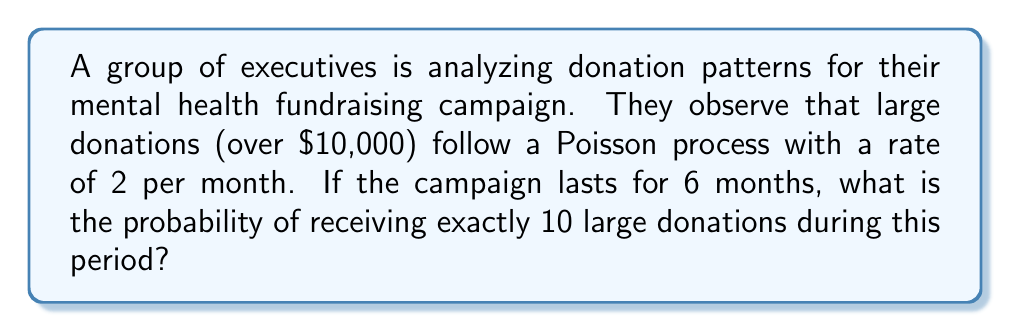Teach me how to tackle this problem. To solve this problem, we'll use the Poisson distribution formula:

$$P(X = k) = \frac{e^{-\lambda} \lambda^k}{k!}$$

Where:
- $\lambda$ is the average number of events in the given time period
- $k$ is the number of events we're interested in
- $e$ is Euler's number (approximately 2.71828)

Step 1: Calculate $\lambda$ for the entire 6-month period
$\lambda = 2 \text{ donations/month} \times 6 \text{ months} = 12 \text{ donations}$

Step 2: Apply the Poisson distribution formula with $k = 10$ and $\lambda = 12$

$$P(X = 10) = \frac{e^{-12} 12^{10}}{10!}$$

Step 3: Calculate the numerator and denominator separately

Numerator: $e^{-12} \times 12^{10} \approx 0.000006144 \times 61,917,364,224 \approx 380.4$

Denominator: $10! = 3,628,800$

Step 4: Divide the numerator by the denominator

$$P(X = 10) = \frac{380.4}{3,628,800} \approx 0.1048$$

Step 5: Convert to a percentage
$0.1048 \times 100\% \approx 10.48\%$

Therefore, the probability of receiving exactly 10 large donations during the 6-month campaign is approximately 10.48%.
Answer: 10.48% 